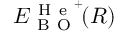<formula> <loc_0><loc_0><loc_500><loc_500>E _ { B O } ^ { H e ^ { + } } \, ( R )</formula> 